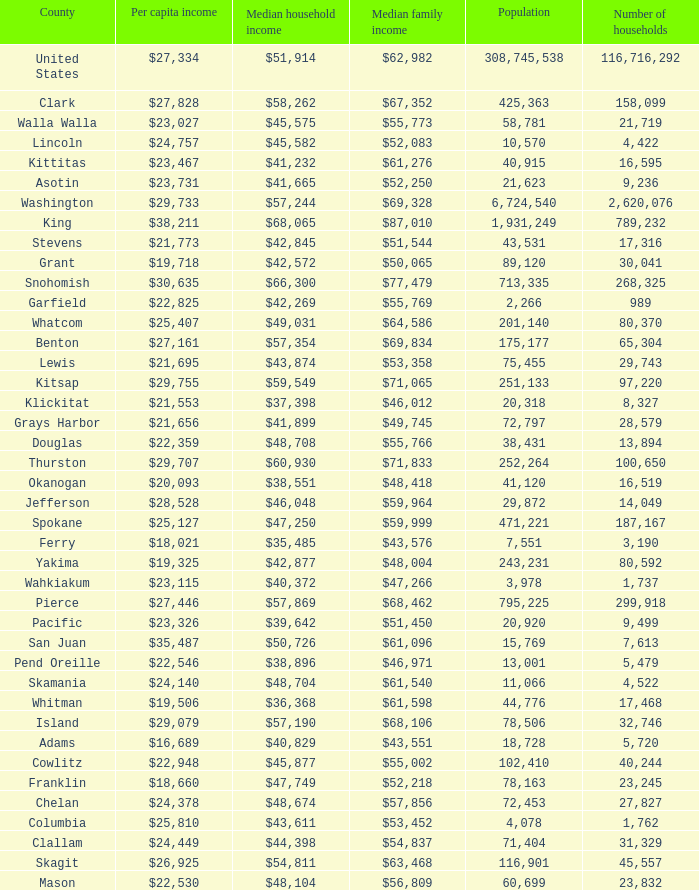Could you parse the entire table? {'header': ['County', 'Per capita income', 'Median household income', 'Median family income', 'Population', 'Number of households'], 'rows': [['United States', '$27,334', '$51,914', '$62,982', '308,745,538', '116,716,292'], ['Clark', '$27,828', '$58,262', '$67,352', '425,363', '158,099'], ['Walla Walla', '$23,027', '$45,575', '$55,773', '58,781', '21,719'], ['Lincoln', '$24,757', '$45,582', '$52,083', '10,570', '4,422'], ['Kittitas', '$23,467', '$41,232', '$61,276', '40,915', '16,595'], ['Asotin', '$23,731', '$41,665', '$52,250', '21,623', '9,236'], ['Washington', '$29,733', '$57,244', '$69,328', '6,724,540', '2,620,076'], ['King', '$38,211', '$68,065', '$87,010', '1,931,249', '789,232'], ['Stevens', '$21,773', '$42,845', '$51,544', '43,531', '17,316'], ['Grant', '$19,718', '$42,572', '$50,065', '89,120', '30,041'], ['Snohomish', '$30,635', '$66,300', '$77,479', '713,335', '268,325'], ['Garfield', '$22,825', '$42,269', '$55,769', '2,266', '989'], ['Whatcom', '$25,407', '$49,031', '$64,586', '201,140', '80,370'], ['Benton', '$27,161', '$57,354', '$69,834', '175,177', '65,304'], ['Lewis', '$21,695', '$43,874', '$53,358', '75,455', '29,743'], ['Kitsap', '$29,755', '$59,549', '$71,065', '251,133', '97,220'], ['Klickitat', '$21,553', '$37,398', '$46,012', '20,318', '8,327'], ['Grays Harbor', '$21,656', '$41,899', '$49,745', '72,797', '28,579'], ['Douglas', '$22,359', '$48,708', '$55,766', '38,431', '13,894'], ['Thurston', '$29,707', '$60,930', '$71,833', '252,264', '100,650'], ['Okanogan', '$20,093', '$38,551', '$48,418', '41,120', '16,519'], ['Jefferson', '$28,528', '$46,048', '$59,964', '29,872', '14,049'], ['Spokane', '$25,127', '$47,250', '$59,999', '471,221', '187,167'], ['Ferry', '$18,021', '$35,485', '$43,576', '7,551', '3,190'], ['Yakima', '$19,325', '$42,877', '$48,004', '243,231', '80,592'], ['Wahkiakum', '$23,115', '$40,372', '$47,266', '3,978', '1,737'], ['Pierce', '$27,446', '$57,869', '$68,462', '795,225', '299,918'], ['Pacific', '$23,326', '$39,642', '$51,450', '20,920', '9,499'], ['San Juan', '$35,487', '$50,726', '$61,096', '15,769', '7,613'], ['Pend Oreille', '$22,546', '$38,896', '$46,971', '13,001', '5,479'], ['Skamania', '$24,140', '$48,704', '$61,540', '11,066', '4,522'], ['Whitman', '$19,506', '$36,368', '$61,598', '44,776', '17,468'], ['Island', '$29,079', '$57,190', '$68,106', '78,506', '32,746'], ['Adams', '$16,689', '$40,829', '$43,551', '18,728', '5,720'], ['Cowlitz', '$22,948', '$45,877', '$55,002', '102,410', '40,244'], ['Franklin', '$18,660', '$47,749', '$52,218', '78,163', '23,245'], ['Chelan', '$24,378', '$48,674', '$57,856', '72,453', '27,827'], ['Columbia', '$25,810', '$43,611', '$53,452', '4,078', '1,762'], ['Clallam', '$24,449', '$44,398', '$54,837', '71,404', '31,329'], ['Skagit', '$26,925', '$54,811', '$63,468', '116,901', '45,557'], ['Mason', '$22,530', '$48,104', '$56,809', '60,699', '23,832']]} How much is per capita income when median household income is $42,845? $21,773. 